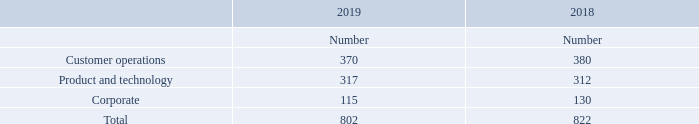7. Employee numbers and costs
The average monthly number of employees (including Executive Directors but excluding third-party contractors) employed by the Group was as follows:
What does the average monthly number of employees include or exclude? Including executive directors but excluding third-party contractors. What is the total average number of employees employed in 2019? 802. What are the categories of employees listed in the table? Customer operations, product and technology, corporate. In which year was Product and technology larger? 317>312
Answer: 2019. What was the change in Corporate in 2019 from 2018? 115-130
Answer: -15. What was the percentage change in Corporate in 2019 from 2018?
Answer scale should be: percent. (115-130)/130
Answer: -11.54. 